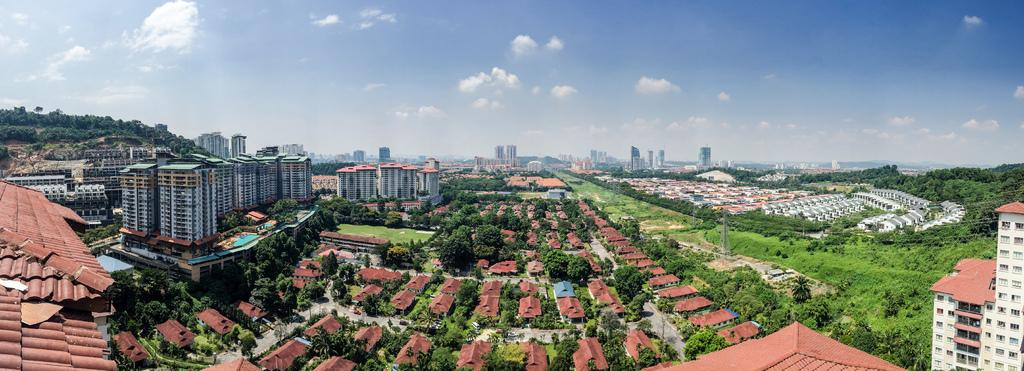What type of structures can be seen in the image? There are buildings and houses in the image. What natural elements are present in the image? There are trees and grass in the image. What is visible at the top of the image? The sky is visible at the top of the image. What type of voyage is depicted in the image? There is no voyage depicted in the image; it features buildings, houses, trees, grass, and the sky. Can you see a beetle crawling on the grass in the image? There is no beetle present in the image; it only shows buildings, houses, trees, grass, and the sky. 